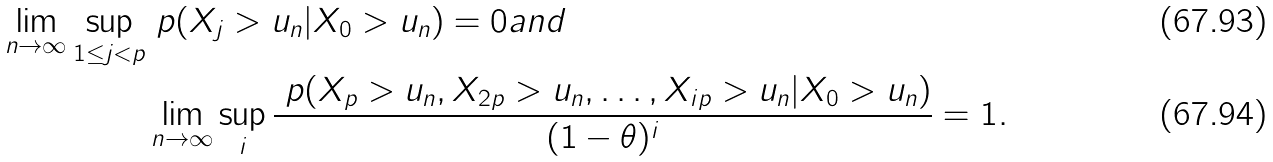Convert formula to latex. <formula><loc_0><loc_0><loc_500><loc_500>\lim _ { n \to \infty } \sup _ { 1 \leq j < p } & \ p ( X _ { j } > u _ { n } | X _ { 0 } > u _ { n } ) = 0 a n d \\ & \lim _ { n \to \infty } \sup _ { i } \frac { \ p ( X _ { p } > u _ { n } , X _ { 2 p } > u _ { n } , \dots , X _ { i p } > u _ { n } | X _ { 0 } > u _ { n } ) } { ( 1 - \theta ) ^ { i } } = 1 .</formula> 